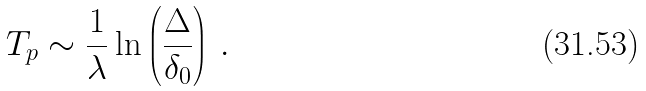Convert formula to latex. <formula><loc_0><loc_0><loc_500><loc_500>T _ { p } \sim \frac { 1 } { \lambda } \ln \left ( \frac { \Delta } { \delta _ { 0 } } \right ) \, .</formula> 